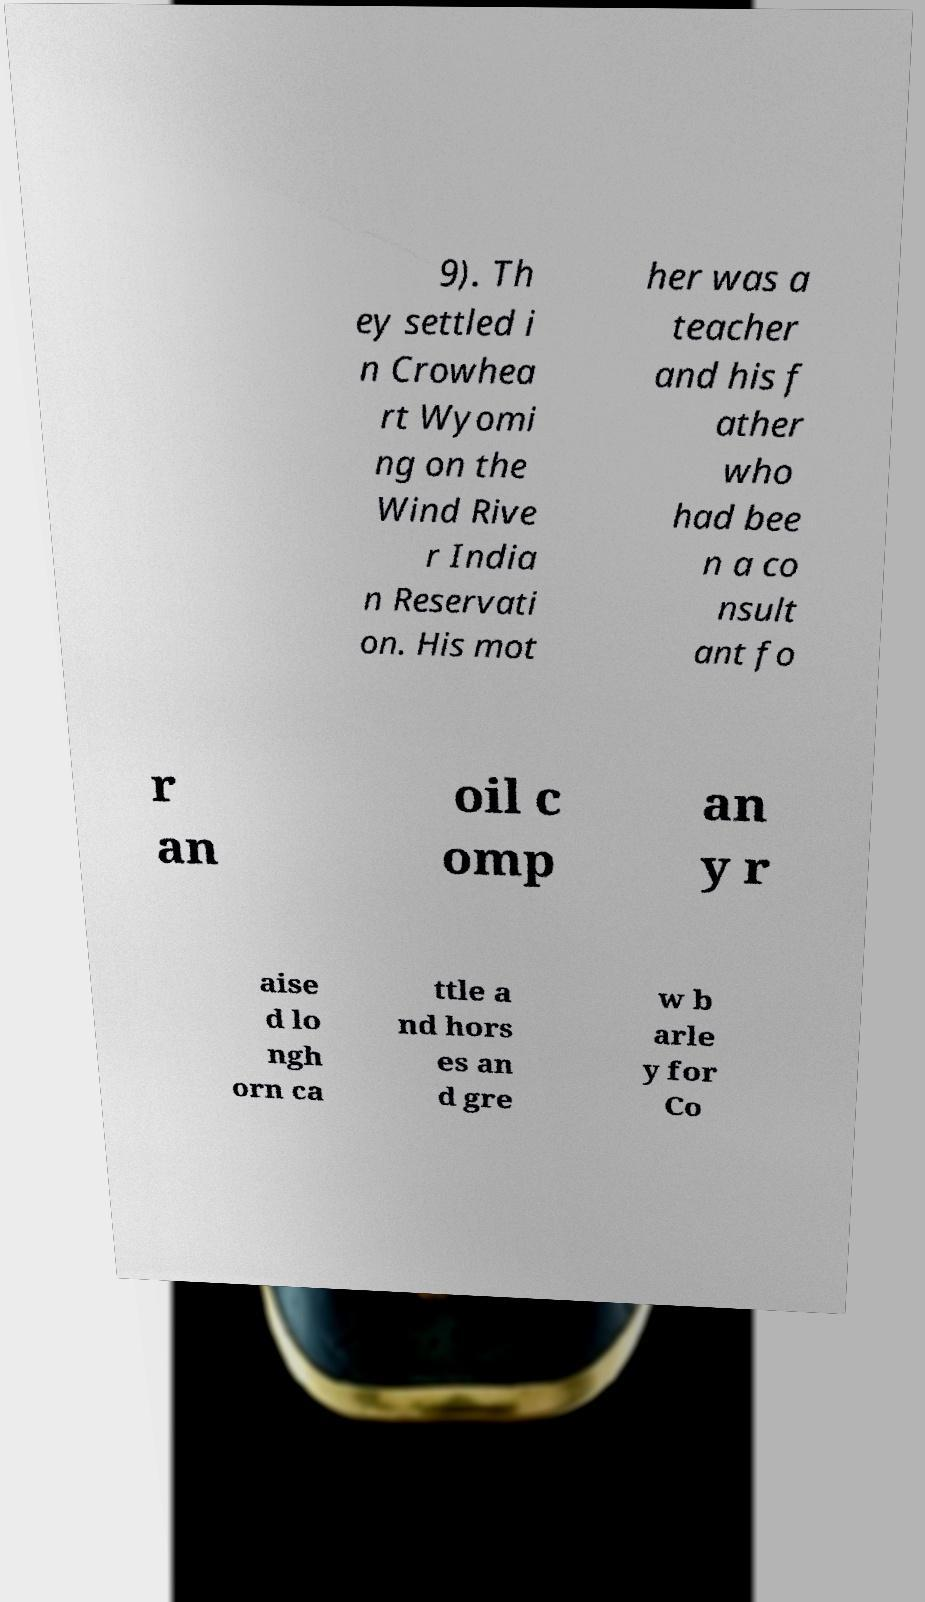Could you assist in decoding the text presented in this image and type it out clearly? 9). Th ey settled i n Crowhea rt Wyomi ng on the Wind Rive r India n Reservati on. His mot her was a teacher and his f ather who had bee n a co nsult ant fo r an oil c omp an y r aise d lo ngh orn ca ttle a nd hors es an d gre w b arle y for Co 